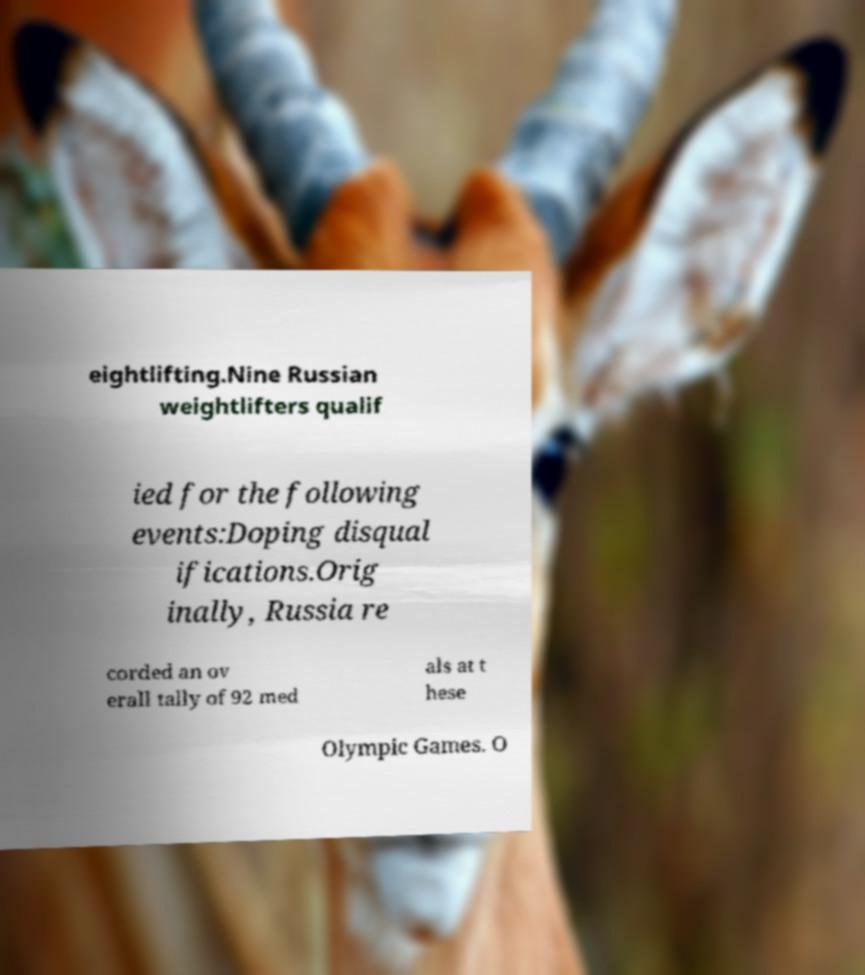I need the written content from this picture converted into text. Can you do that? eightlifting.Nine Russian weightlifters qualif ied for the following events:Doping disqual ifications.Orig inally, Russia re corded an ov erall tally of 92 med als at t hese Olympic Games. O 